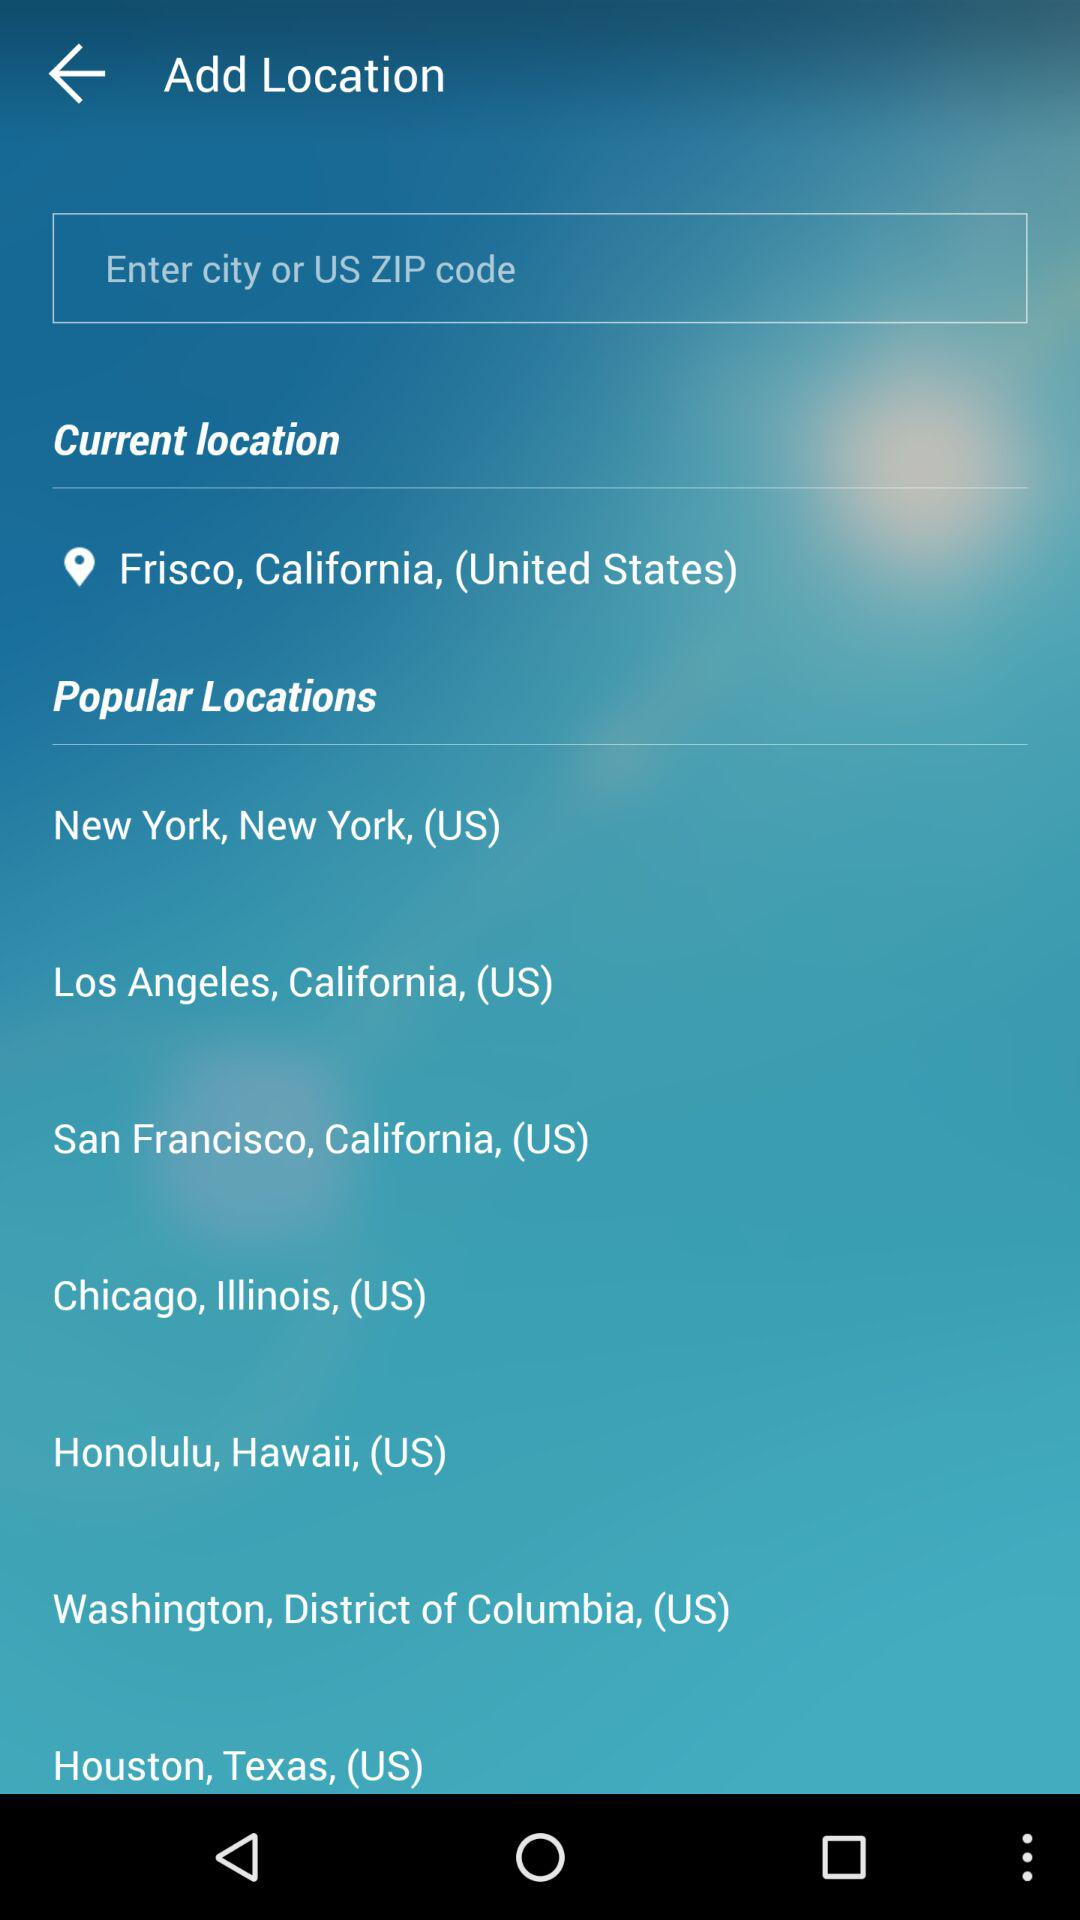What is the current location? The current location is Frisco, California, (United States). 